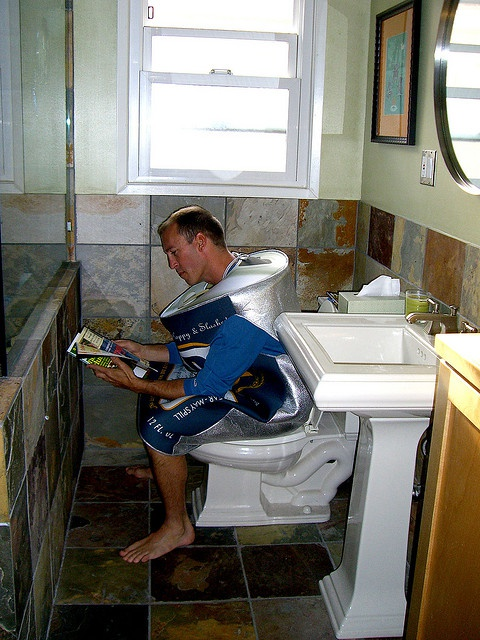Describe the objects in this image and their specific colors. I can see people in gray, black, navy, and maroon tones, toilet in gray, darkgray, lightgray, and black tones, sink in gray, lightgray, darkgray, and olive tones, and book in gray, black, darkgray, and olive tones in this image. 